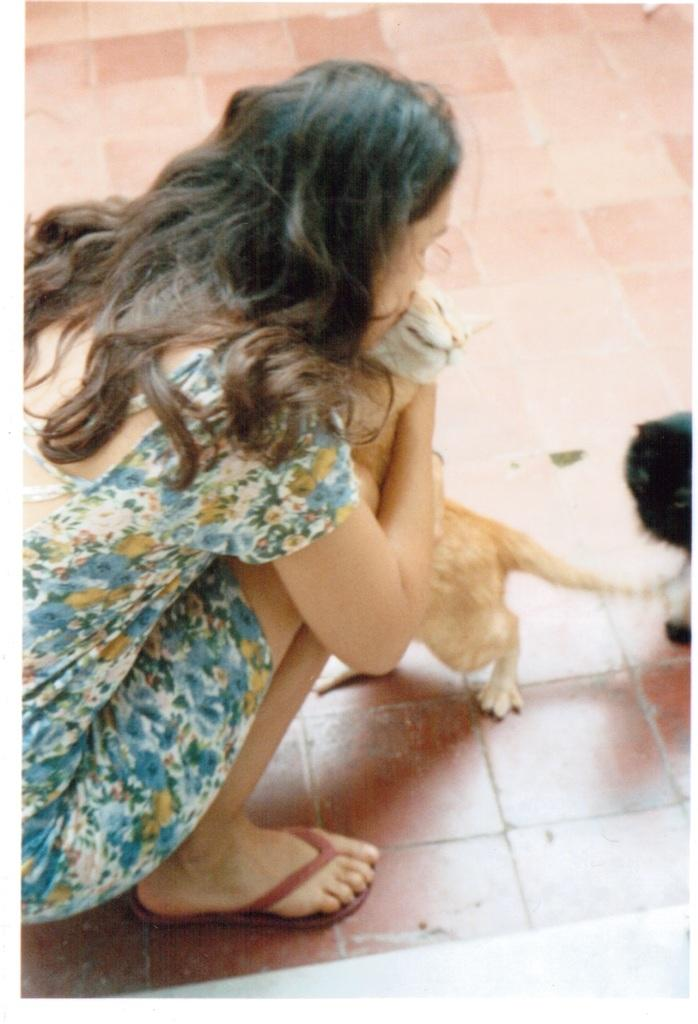Who is the main subject in the foreground of the image? There is a woman in the foreground of the image. What is the woman doing in the image? The woman is squatting on the floor and kissing a cat. Where is the cat located in the image? There is a cat on the floor in the right side of the image. What type of war is depicted in the image? There is no war depicted in the image; it features a woman squatting on the floor and kissing a cat. What role does the calculator play in the image? There is no calculator present in the image. 